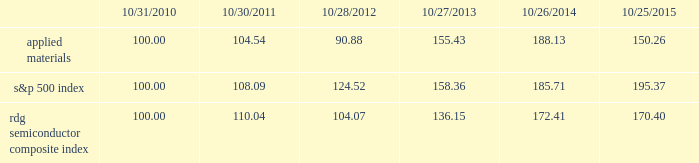Performance graph the performance graph below shows the five-year cumulative total stockholder return on applied common stock during the period from october 31 , 2010 through october 25 , 2015 .
This is compared with the cumulative total return of the standard & poor 2019s 500 stock index and the rdg semiconductor composite index over the same period .
The comparison assumes $ 100 was invested on october 31 , 2010 in applied common stock and in each of the foregoing indices and assumes reinvestment of dividends , if any .
Dollar amounts in the graph are rounded to the nearest whole dollar .
The performance shown in the graph represents past performance and should not be considered an indication of future performance .
Comparison of 5 year cumulative total return* among applied materials , inc. , the s&p 500 index and the rdg semiconductor composite index *assumes $ 100 invested on 10/31/10 in stock or index , including reinvestment of dividends .
Indexes calculated on month-end basis .
201cs&p 201d is a registered trademark of standard & poor 2019s financial services llc , a subsidiary of the mcgraw-hill companies , inc. .
Dividends during each of fiscal 2015 and 2014 , applied's board of directors declared four quarterly cash dividends of $ 0.10 per share .
During fiscal 2013 , applied 2019s board of directors declared three quarterly cash dividends of $ 0.10 per share and one quarterly cash dividend of $ 0.09 per share .
Dividends paid during fiscal 2015 , 2014 and 2013 amounted to $ 487 million , $ 485 million and $ 456 million , respectively .
Applied currently anticipates that cash dividends will continue to be paid on a quarterly basis , although the declaration of any future cash dividend is at the discretion of the board of directors and will depend on applied 2019s financial condition , results of operations , capital requirements , business conditions and other factors , as well as a determination by the board of directors that cash dividends are in the best interests of applied 2019s stockholders .
104 136 10/31/10 10/30/11 10/28/12 10/27/13 10/26/14 10/25/15 applied materials , inc .
S&p 500 rdg semiconductor composite .
What is the yearly rate of return of s&p500 if the investment occurs in 2010 and it is liquidated one year later? 
Computations: ((108.09 - 100) / 100)
Answer: 0.0809. 